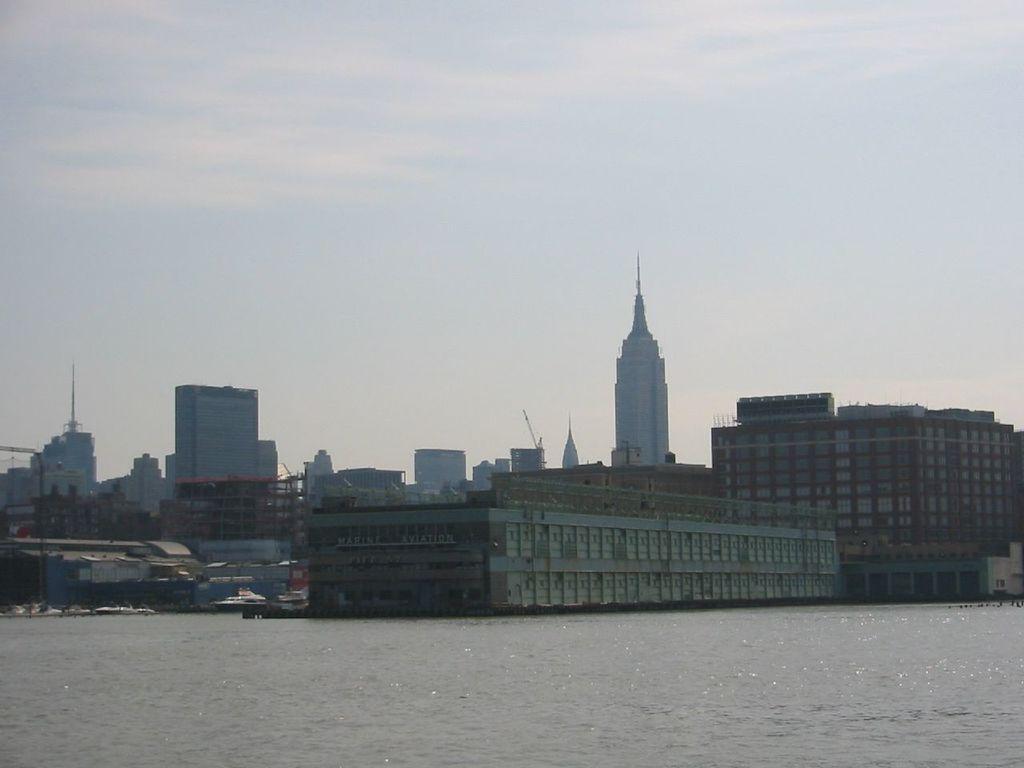How would you summarize this image in a sentence or two? We can observe a river in this picture. There are buildings. In the background there is a sky. 